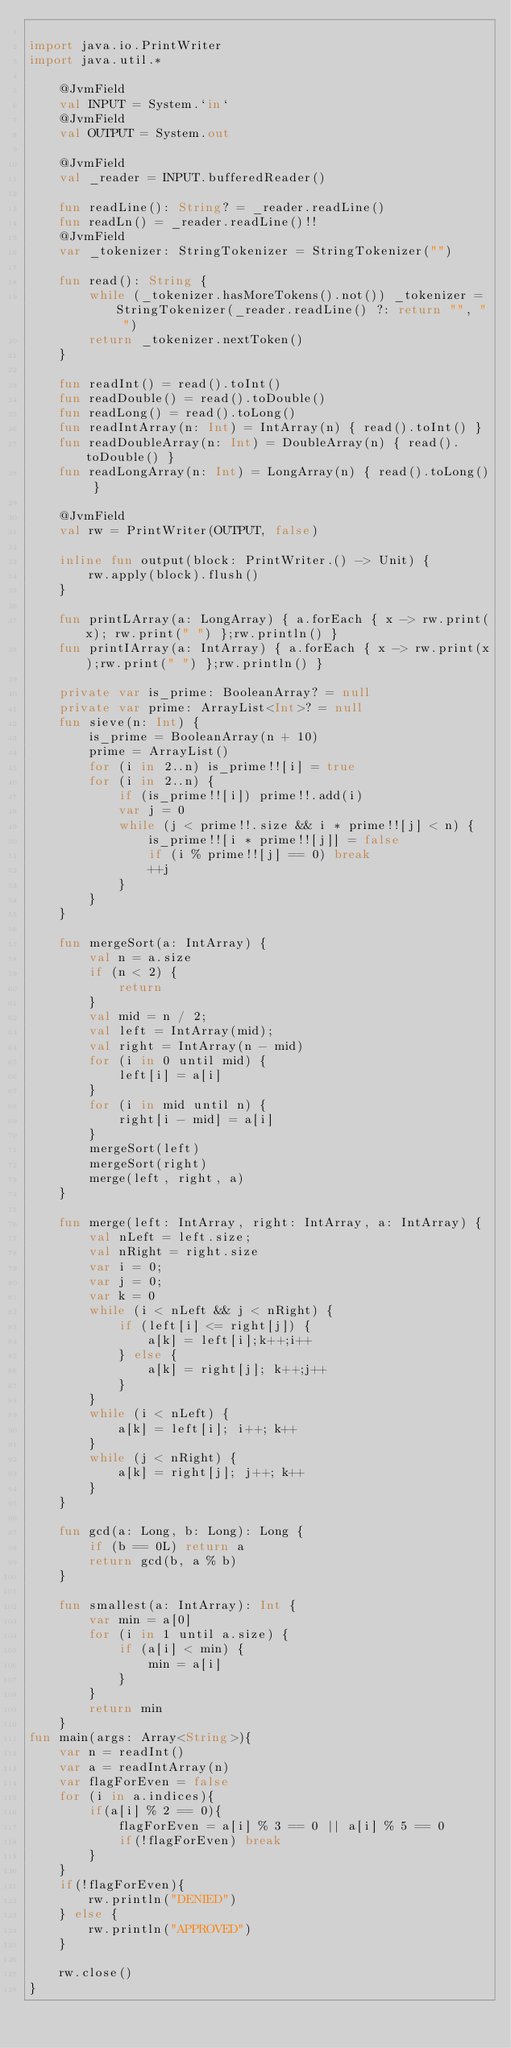<code> <loc_0><loc_0><loc_500><loc_500><_Kotlin_>
import java.io.PrintWriter
import java.util.*

    @JvmField
    val INPUT = System.`in`
    @JvmField
    val OUTPUT = System.out

    @JvmField
    val _reader = INPUT.bufferedReader()

    fun readLine(): String? = _reader.readLine()
    fun readLn() = _reader.readLine()!!
    @JvmField
    var _tokenizer: StringTokenizer = StringTokenizer("")

    fun read(): String {
        while (_tokenizer.hasMoreTokens().not()) _tokenizer = StringTokenizer(_reader.readLine() ?: return "", " ")
        return _tokenizer.nextToken()
    }

    fun readInt() = read().toInt()
    fun readDouble() = read().toDouble()
    fun readLong() = read().toLong()
    fun readIntArray(n: Int) = IntArray(n) { read().toInt() }
    fun readDoubleArray(n: Int) = DoubleArray(n) { read().toDouble() }
    fun readLongArray(n: Int) = LongArray(n) { read().toLong() }

    @JvmField
    val rw = PrintWriter(OUTPUT, false)

    inline fun output(block: PrintWriter.() -> Unit) {
        rw.apply(block).flush()
    }

    fun printLArray(a: LongArray) { a.forEach { x -> rw.print(x); rw.print(" ") };rw.println() }
    fun printIArray(a: IntArray) { a.forEach { x -> rw.print(x);rw.print(" ") };rw.println() }

    private var is_prime: BooleanArray? = null
    private var prime: ArrayList<Int>? = null
    fun sieve(n: Int) {
        is_prime = BooleanArray(n + 10)
        prime = ArrayList()
        for (i in 2..n) is_prime!![i] = true
        for (i in 2..n) {
            if (is_prime!![i]) prime!!.add(i)
            var j = 0
            while (j < prime!!.size && i * prime!![j] < n) {
                is_prime!![i * prime!![j]] = false
                if (i % prime!![j] == 0) break
                ++j
            }
        }
    }

    fun mergeSort(a: IntArray) {
        val n = a.size
        if (n < 2) {
            return
        }
        val mid = n / 2;
        val left = IntArray(mid);
        val right = IntArray(n - mid)
        for (i in 0 until mid) {
            left[i] = a[i]
        }
        for (i in mid until n) {
            right[i - mid] = a[i]
        }
        mergeSort(left)
        mergeSort(right)
        merge(left, right, a)
    }

    fun merge(left: IntArray, right: IntArray, a: IntArray) {
        val nLeft = left.size;
        val nRight = right.size
        var i = 0;
        var j = 0;
        var k = 0
        while (i < nLeft && j < nRight) {
            if (left[i] <= right[j]) {
                a[k] = left[i];k++;i++
            } else {
                a[k] = right[j]; k++;j++
            }
        }
        while (i < nLeft) {
            a[k] = left[i]; i++; k++
        }
        while (j < nRight) {
            a[k] = right[j]; j++; k++
        }
    }

    fun gcd(a: Long, b: Long): Long {
        if (b == 0L) return a
        return gcd(b, a % b)
    }

    fun smallest(a: IntArray): Int {
        var min = a[0]
        for (i in 1 until a.size) {
            if (a[i] < min) {
                min = a[i]
            }
        }
        return min
    }
fun main(args: Array<String>){
    var n = readInt()
    var a = readIntArray(n)
    var flagForEven = false
    for (i in a.indices){
        if(a[i] % 2 == 0){
            flagForEven = a[i] % 3 == 0 || a[i] % 5 == 0
            if(!flagForEven) break
        }
    }
    if(!flagForEven){
        rw.println("DENIED")
    } else {
        rw.println("APPROVED")
    }

    rw.close()
}</code> 